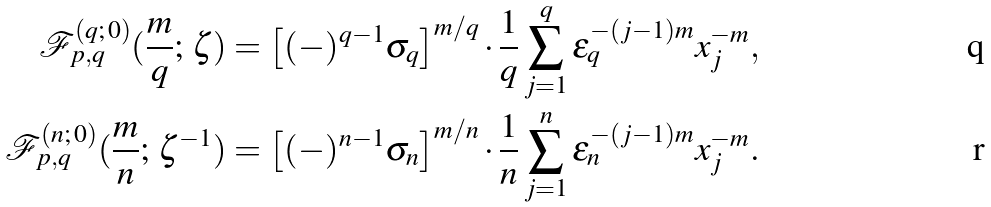<formula> <loc_0><loc_0><loc_500><loc_500>\mathcal { F } _ { p , q } ^ { ( q ; \, 0 ) } ( \frac { m } q ; \, \zeta ) & = \left [ ( - ) ^ { q - 1 } \sigma _ { q } \right ] ^ { m / q } \cdot \frac { 1 } { q } \sum _ { j = 1 } ^ { q } \varepsilon _ { q } ^ { - ( j - 1 ) m } x _ { j } ^ { - m } , \\ \mathcal { F } _ { p , q } ^ { ( n ; \, 0 ) } ( \frac { m } n ; \, \zeta ^ { - 1 } ) & = \left [ ( - ) ^ { n - 1 } \sigma _ { n } \right ] ^ { m / n } \cdot \frac { 1 } { n } \sum _ { j = 1 } ^ { n } \varepsilon _ { n } ^ { - ( j - 1 ) m } x _ { j } ^ { - m } .</formula> 